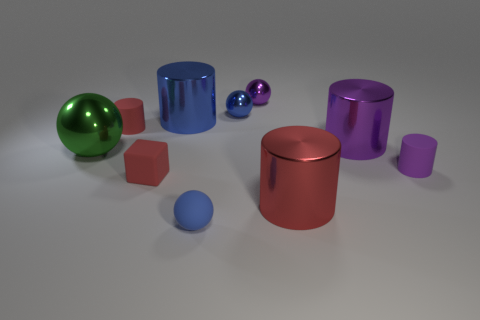Subtract 2 spheres. How many spheres are left? 2 Subtract all blue cylinders. How many cylinders are left? 4 Subtract all red metal cylinders. How many cylinders are left? 4 Subtract all blue cylinders. Subtract all purple cubes. How many cylinders are left? 4 Subtract all cubes. How many objects are left? 9 Subtract 1 purple cylinders. How many objects are left? 9 Subtract all big green balls. Subtract all purple spheres. How many objects are left? 8 Add 3 large red metal cylinders. How many large red metal cylinders are left? 4 Add 4 small purple metal cylinders. How many small purple metal cylinders exist? 4 